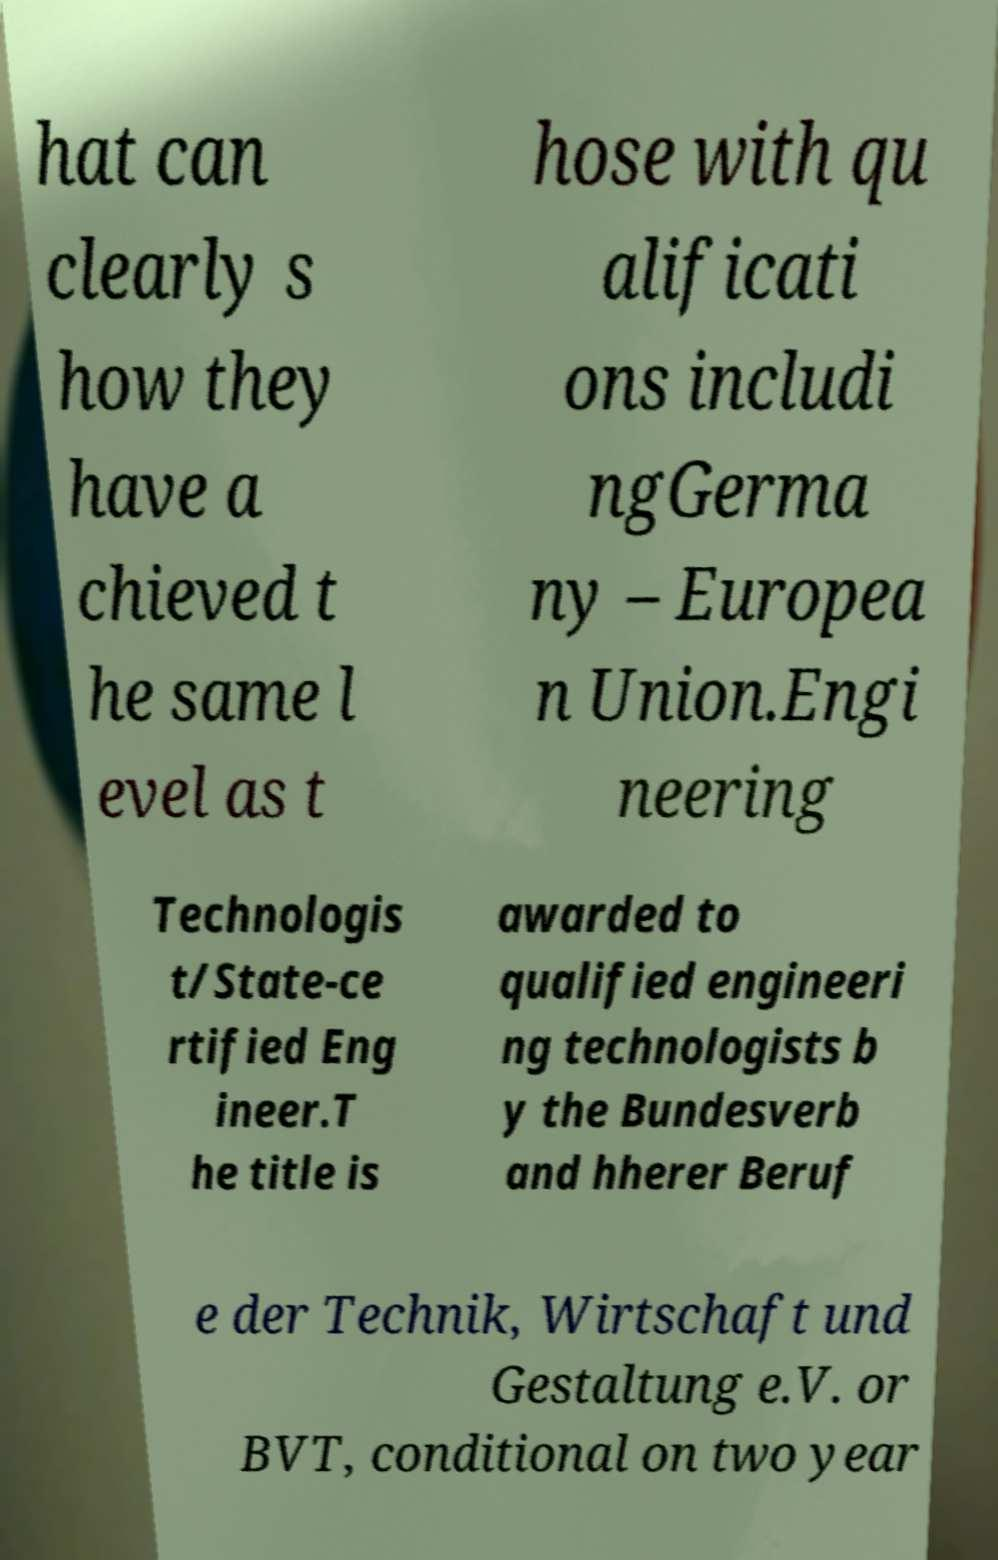What messages or text are displayed in this image? I need them in a readable, typed format. hat can clearly s how they have a chieved t he same l evel as t hose with qu alificati ons includi ngGerma ny – Europea n Union.Engi neering Technologis t/State-ce rtified Eng ineer.T he title is awarded to qualified engineeri ng technologists b y the Bundesverb and hherer Beruf e der Technik, Wirtschaft und Gestaltung e.V. or BVT, conditional on two year 